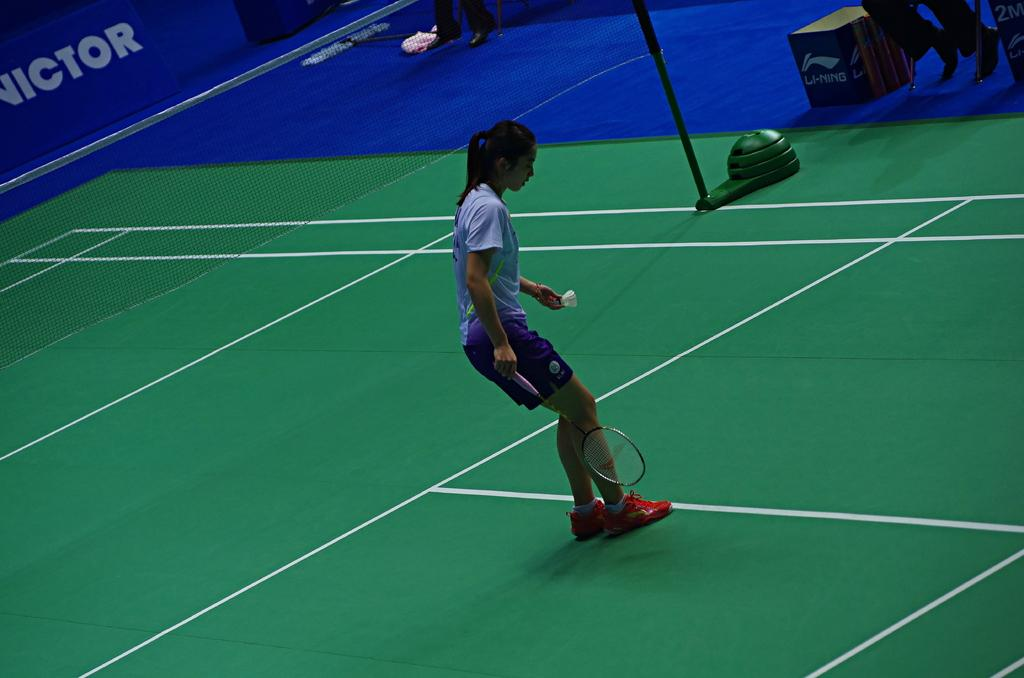Who is present in the image? There is a woman in the image. What is the woman wearing? The woman is wearing a blue dress. What is the woman doing in the image? The woman is standing and holding a badminton bat and a shuttlecock. What is located beside the woman? There is a net beside the woman. How does the woman compare the rice in the image? There is no rice present in the image, so it is not possible to answer a question about comparing rice. 